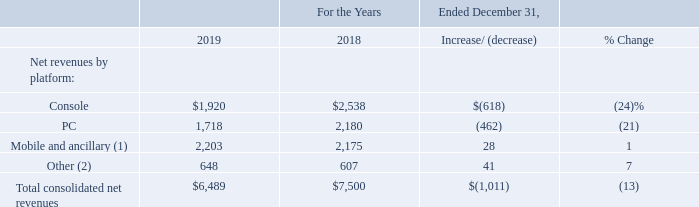Net Revenues by Platform
The following tables detail our net revenues by platform (amounts in millions):
(1) Net revenues from “Mobile and ancillary” include revenues from mobile devices, as well as non-platform-specific game-related revenues, such as standalone sales of toys and accessories.
(2) Net revenues from “Other” primarily includes revenues from our Distribution business and the Overwatch League.
Console
The decrease in net revenues from console for 2019, as compared to 2018, was primarily due to:
lower revenues recognized from the Destiny franchise (reflecting our sale of the publishing rights for Destiny to Bungie in December 2018); and lower revenues recognized from Call of Duty franchise catalog titles.
The decrease was partially offset by revenues recognized from Crash Team Racing Nitro-Fueled, which was released in June 2019.
PC
The decrease in net revenues from PC for 2019, as compared to 2018, was primarily due to:
lower revenues recognized from the Destiny franchise; and lower revenues recognized from Hearthstone.
Mobile and Ancillary
The increase in net revenues from mobile and ancillary for 2019, as compared to 2018, was primarily due to revenues recognized from Call of Duty: Mobile, which was released in October 2019.
What does Net revenues from “Mobile and ancillary” include? Revenues from mobile devices, as well as non-platform-specific game-related revenues, such as standalone sales of toys and accessories. What does Net revenues from “Other” include? Revenues from our distribution business and the overwatch league. What is the net revenue from Console in 2019?
Answer scale should be: million. $1,920. What is the total consolidated net revenues of Console PC in 2019?
Answer scale should be: million. $1,920+1,718
Answer: 3638. What is the total consolidated net revenues of Console PC in 2018?
Answer scale should be: million. $2,538+2,180
Answer: 4718. What is the percentage of total consolidated net revenues in 2019 that consists of net revenue from PC?
Answer scale should be: percent. ($1,718/$6,489)
Answer: 26.48. 